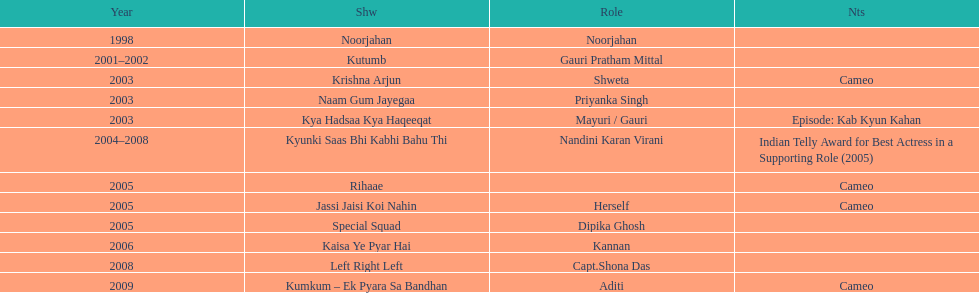The shows with at most 1 cameo Krishna Arjun, Rihaae, Jassi Jaisi Koi Nahin, Kumkum - Ek Pyara Sa Bandhan. Would you mind parsing the complete table? {'header': ['Year', 'Shw', 'Role', 'Nts'], 'rows': [['1998', 'Noorjahan', 'Noorjahan', ''], ['2001–2002', 'Kutumb', 'Gauri Pratham Mittal', ''], ['2003', 'Krishna Arjun', 'Shweta', 'Cameo'], ['2003', 'Naam Gum Jayegaa', 'Priyanka Singh', ''], ['2003', 'Kya Hadsaa Kya Haqeeqat', 'Mayuri / Gauri', 'Episode: Kab Kyun Kahan'], ['2004–2008', 'Kyunki Saas Bhi Kabhi Bahu Thi', 'Nandini Karan Virani', 'Indian Telly Award for Best Actress in a Supporting Role (2005)'], ['2005', 'Rihaae', '', 'Cameo'], ['2005', 'Jassi Jaisi Koi Nahin', 'Herself', 'Cameo'], ['2005', 'Special Squad', 'Dipika Ghosh', ''], ['2006', 'Kaisa Ye Pyar Hai', 'Kannan', ''], ['2008', 'Left Right Left', 'Capt.Shona Das', ''], ['2009', 'Kumkum – Ek Pyara Sa Bandhan', 'Aditi', 'Cameo']]} 